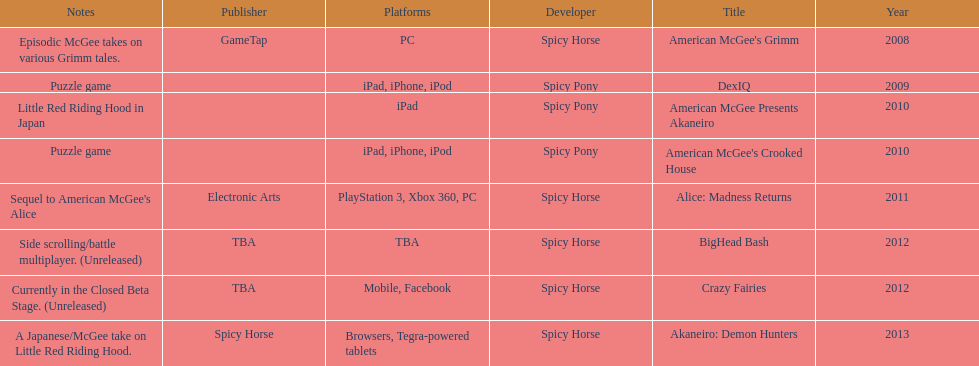Which title is for ipad but not for iphone or ipod? American McGee Presents Akaneiro. Parse the full table. {'header': ['Notes', 'Publisher', 'Platforms', 'Developer', 'Title', 'Year'], 'rows': [['Episodic McGee takes on various Grimm tales.', 'GameTap', 'PC', 'Spicy Horse', "American McGee's Grimm", '2008'], ['Puzzle game', '', 'iPad, iPhone, iPod', 'Spicy Pony', 'DexIQ', '2009'], ['Little Red Riding Hood in Japan', '', 'iPad', 'Spicy Pony', 'American McGee Presents Akaneiro', '2010'], ['Puzzle game', '', 'iPad, iPhone, iPod', 'Spicy Pony', "American McGee's Crooked House", '2010'], ["Sequel to American McGee's Alice", 'Electronic Arts', 'PlayStation 3, Xbox 360, PC', 'Spicy Horse', 'Alice: Madness Returns', '2011'], ['Side scrolling/battle multiplayer. (Unreleased)', 'TBA', 'TBA', 'Spicy Horse', 'BigHead Bash', '2012'], ['Currently in the Closed Beta Stage. (Unreleased)', 'TBA', 'Mobile, Facebook', 'Spicy Horse', 'Crazy Fairies', '2012'], ['A Japanese/McGee take on Little Red Riding Hood.', 'Spicy Horse', 'Browsers, Tegra-powered tablets', 'Spicy Horse', 'Akaneiro: Demon Hunters', '2013']]} 